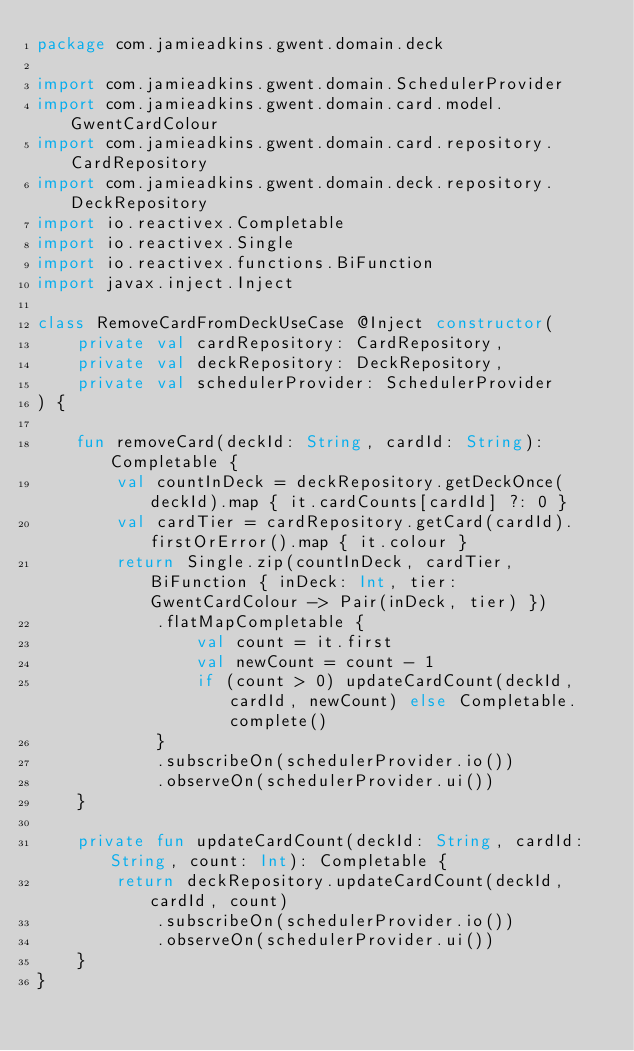Convert code to text. <code><loc_0><loc_0><loc_500><loc_500><_Kotlin_>package com.jamieadkins.gwent.domain.deck

import com.jamieadkins.gwent.domain.SchedulerProvider
import com.jamieadkins.gwent.domain.card.model.GwentCardColour
import com.jamieadkins.gwent.domain.card.repository.CardRepository
import com.jamieadkins.gwent.domain.deck.repository.DeckRepository
import io.reactivex.Completable
import io.reactivex.Single
import io.reactivex.functions.BiFunction
import javax.inject.Inject

class RemoveCardFromDeckUseCase @Inject constructor(
    private val cardRepository: CardRepository,
    private val deckRepository: DeckRepository,
    private val schedulerProvider: SchedulerProvider
) {

    fun removeCard(deckId: String, cardId: String): Completable {
        val countInDeck = deckRepository.getDeckOnce(deckId).map { it.cardCounts[cardId] ?: 0 }
        val cardTier = cardRepository.getCard(cardId).firstOrError().map { it.colour }
        return Single.zip(countInDeck, cardTier, BiFunction { inDeck: Int, tier: GwentCardColour -> Pair(inDeck, tier) })
            .flatMapCompletable {
                val count = it.first
                val newCount = count - 1
                if (count > 0) updateCardCount(deckId, cardId, newCount) else Completable.complete()
            }
            .subscribeOn(schedulerProvider.io())
            .observeOn(schedulerProvider.ui())
    }

    private fun updateCardCount(deckId: String, cardId: String, count: Int): Completable {
        return deckRepository.updateCardCount(deckId, cardId, count)
            .subscribeOn(schedulerProvider.io())
            .observeOn(schedulerProvider.ui())
    }
}</code> 